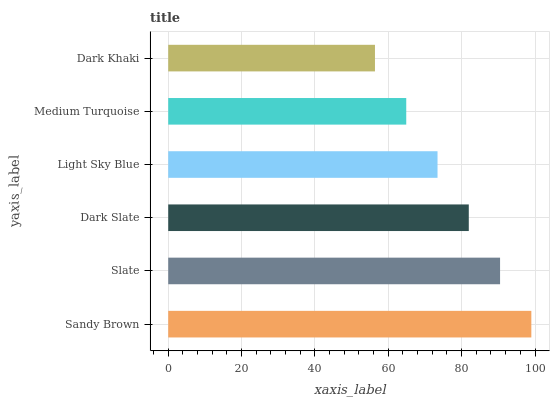Is Dark Khaki the minimum?
Answer yes or no. Yes. Is Sandy Brown the maximum?
Answer yes or no. Yes. Is Slate the minimum?
Answer yes or no. No. Is Slate the maximum?
Answer yes or no. No. Is Sandy Brown greater than Slate?
Answer yes or no. Yes. Is Slate less than Sandy Brown?
Answer yes or no. Yes. Is Slate greater than Sandy Brown?
Answer yes or no. No. Is Sandy Brown less than Slate?
Answer yes or no. No. Is Dark Slate the high median?
Answer yes or no. Yes. Is Light Sky Blue the low median?
Answer yes or no. Yes. Is Sandy Brown the high median?
Answer yes or no. No. Is Medium Turquoise the low median?
Answer yes or no. No. 